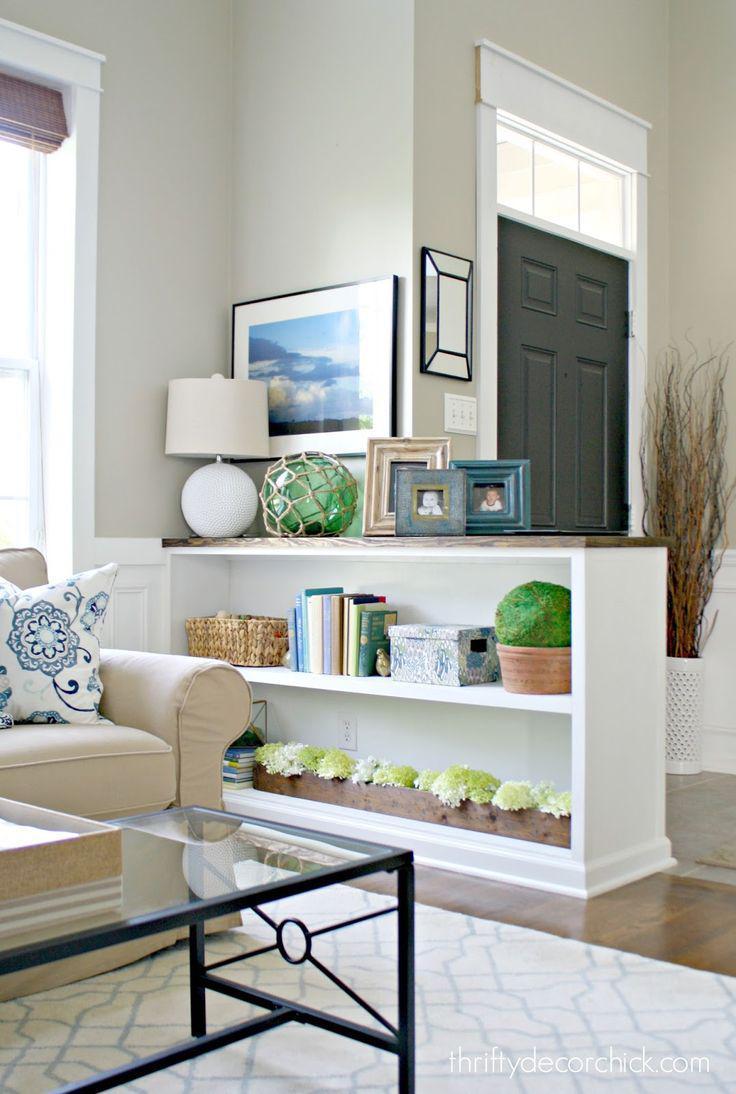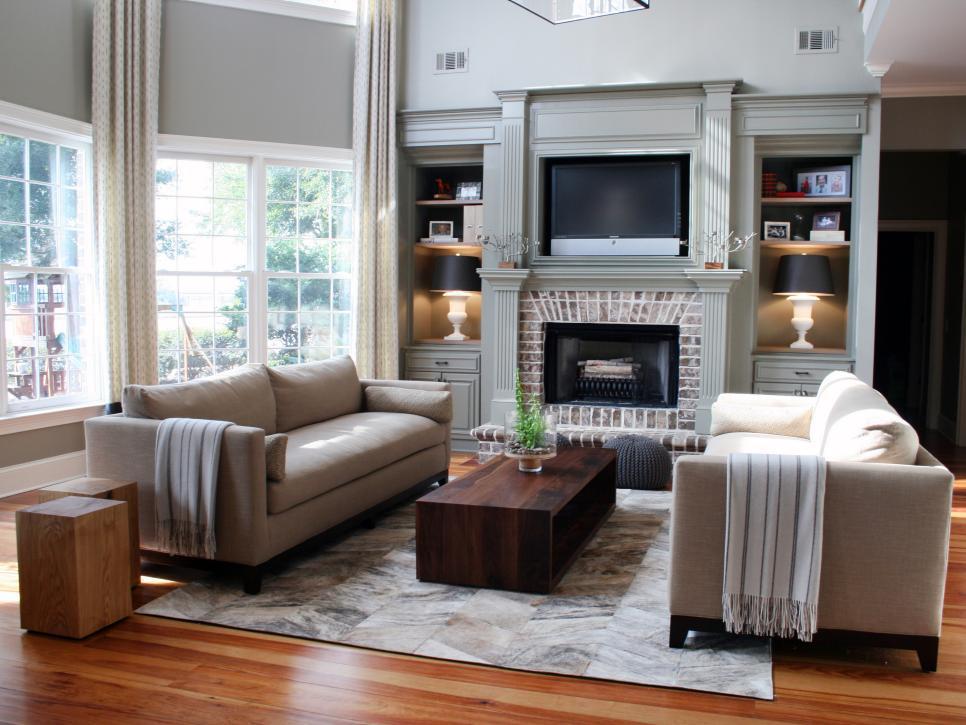The first image is the image on the left, the second image is the image on the right. Examine the images to the left and right. Is the description "There is a TV above a fireplace in the right image." accurate? Answer yes or no. Yes. The first image is the image on the left, the second image is the image on the right. Given the left and right images, does the statement "In at least one image, a fireplace with an overhead television is flanked by shelves." hold true? Answer yes or no. Yes. 